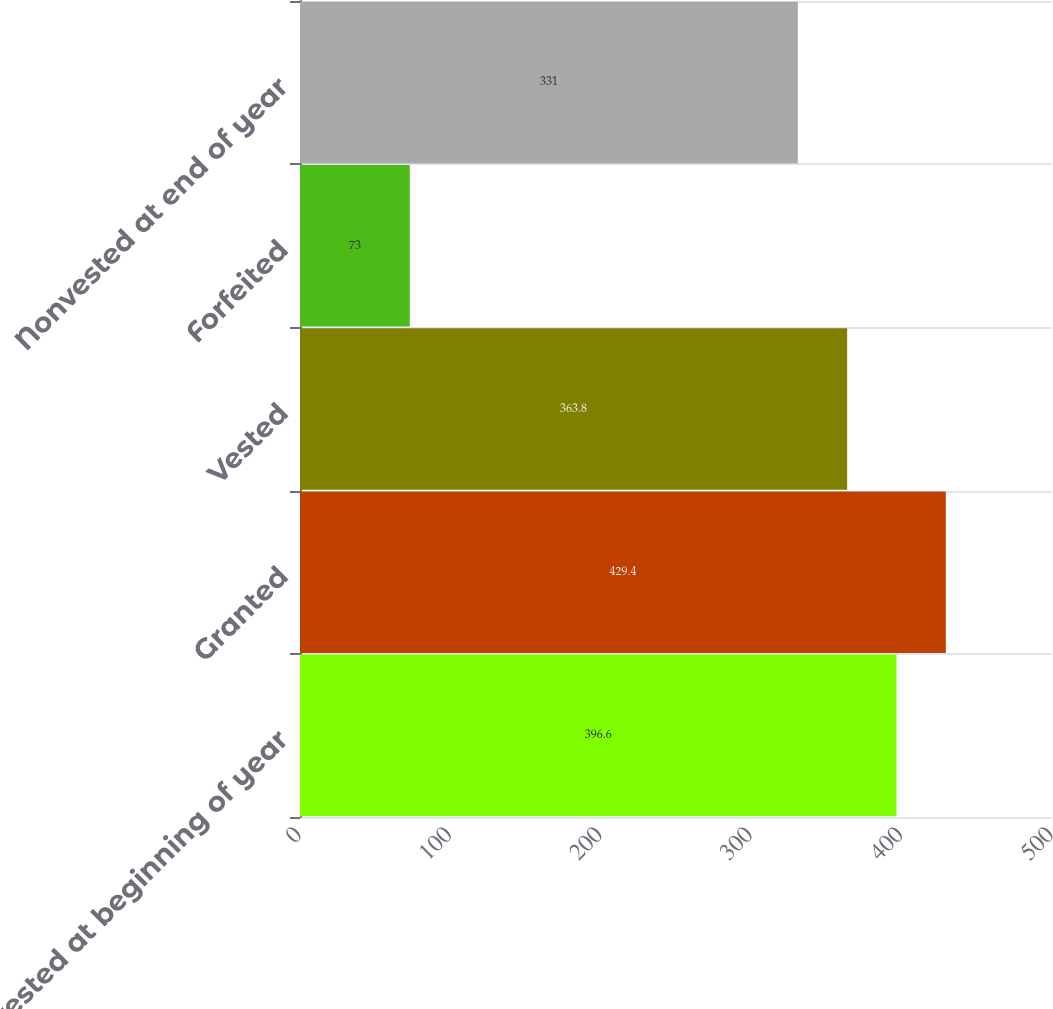Convert chart. <chart><loc_0><loc_0><loc_500><loc_500><bar_chart><fcel>Nonvested at beginning of year<fcel>Granted<fcel>Vested<fcel>Forfeited<fcel>Nonvested at end of year<nl><fcel>396.6<fcel>429.4<fcel>363.8<fcel>73<fcel>331<nl></chart> 